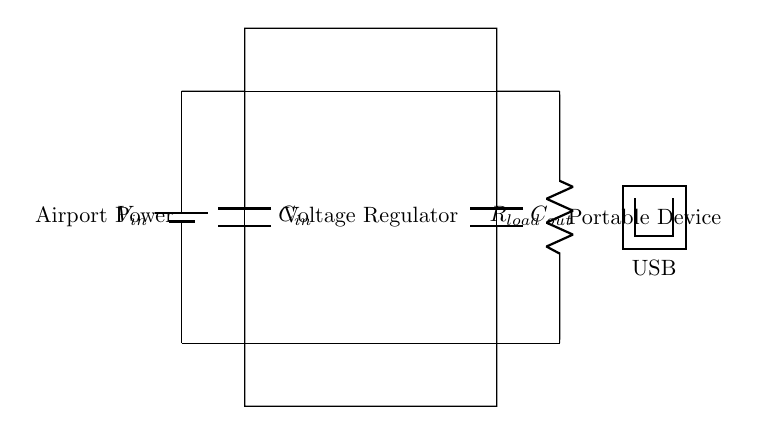What is the input voltage source labeled as? The input voltage source is labeled as V_in, indicating it is the source providing voltage to the circuit.
Answer: V_in What is the load resistor labeled as? The load resistor in the circuit is labeled as R_load, which represents the resistive load connected to the output of the voltage regulator.
Answer: R_load What components are used for filtering in this circuit? The components used for filtering in the circuit are C_in and C_out, which are capacitors connected at the input and output of the voltage regulator.
Answer: C_in and C_out What function does the voltage regulator serve in this circuit? The voltage regulator's function is to provide a stable output voltage level, despite variations in the input voltage or load conditions.
Answer: Stabilizes voltage How are the capacitors connected in relation to the voltage regulator? The capacitors are connected in parallel with the input and output terminals of the voltage regulator, ensuring smooth voltage supply and reducing voltage ripple.
Answer: In parallel What is the purpose of including a USB symbol in the circuit? The USB symbol indicates the intended output connection type for the portable device, providing a standardized interface for charging or powering devices.
Answer: USB connection Which component is responsible for limiting current to the load? The load resistor, R_load, acts as the component responsible for limiting the current drawn by the connected portable device based on its resistance.
Answer: R_load 